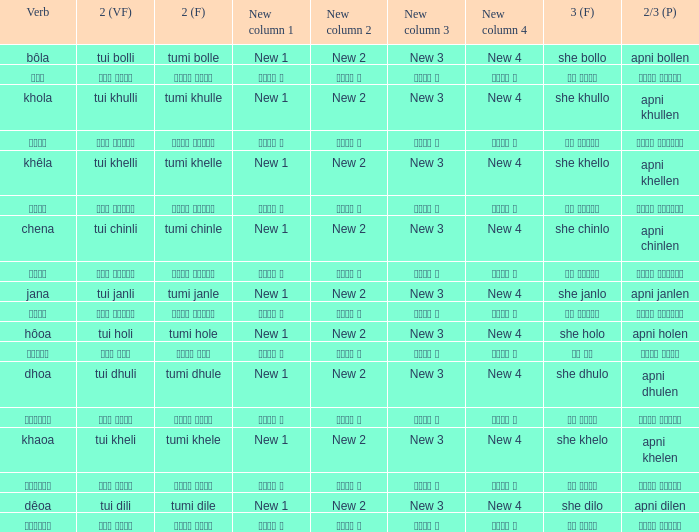What is the action word for তুমি খেলে? খাওয়া. 